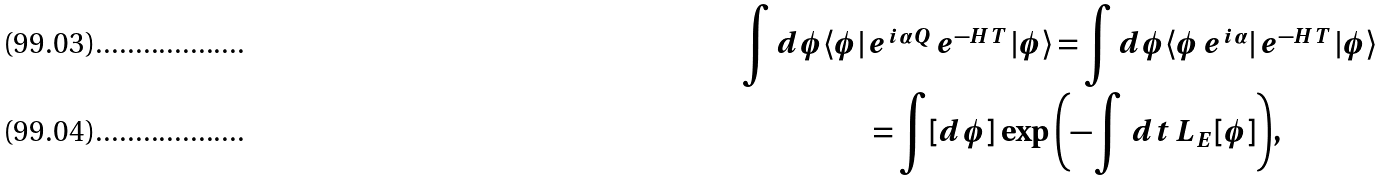<formula> <loc_0><loc_0><loc_500><loc_500>\int d \phi \langle \phi | \, & e ^ { i \alpha Q } \, e ^ { - H T } \, | \phi \rangle = \int d \phi \langle \phi \, e ^ { i \alpha } | \, e ^ { - H T } \, | \phi \rangle \\ & = \int [ d \phi ] \, \exp { \left ( - \int \, d t \, L _ { E } [ \phi ] \right ) } ,</formula> 